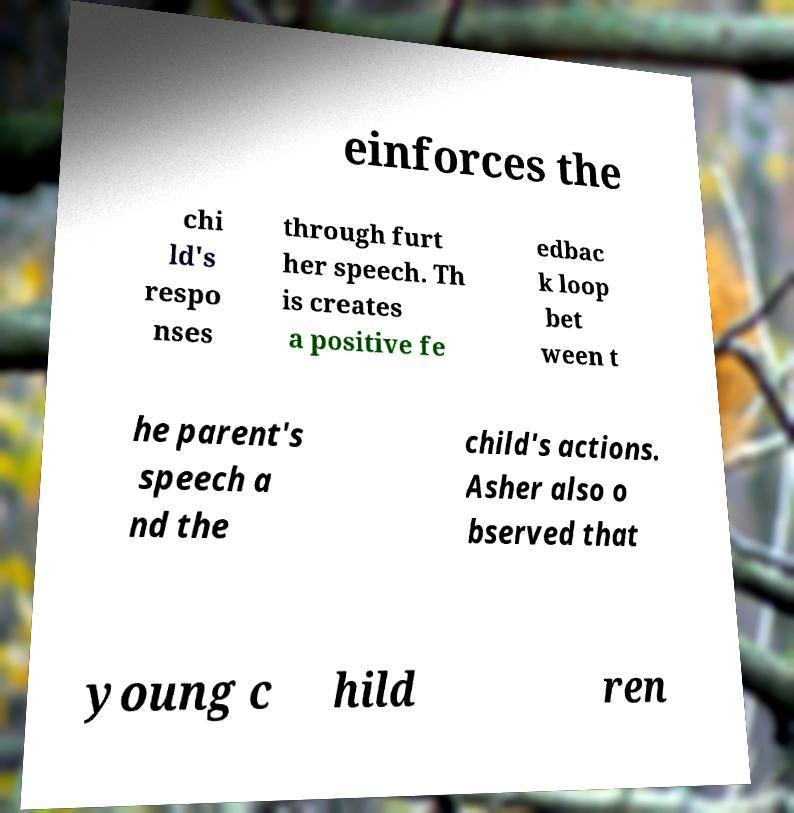I need the written content from this picture converted into text. Can you do that? einforces the chi ld's respo nses through furt her speech. Th is creates a positive fe edbac k loop bet ween t he parent's speech a nd the child's actions. Asher also o bserved that young c hild ren 